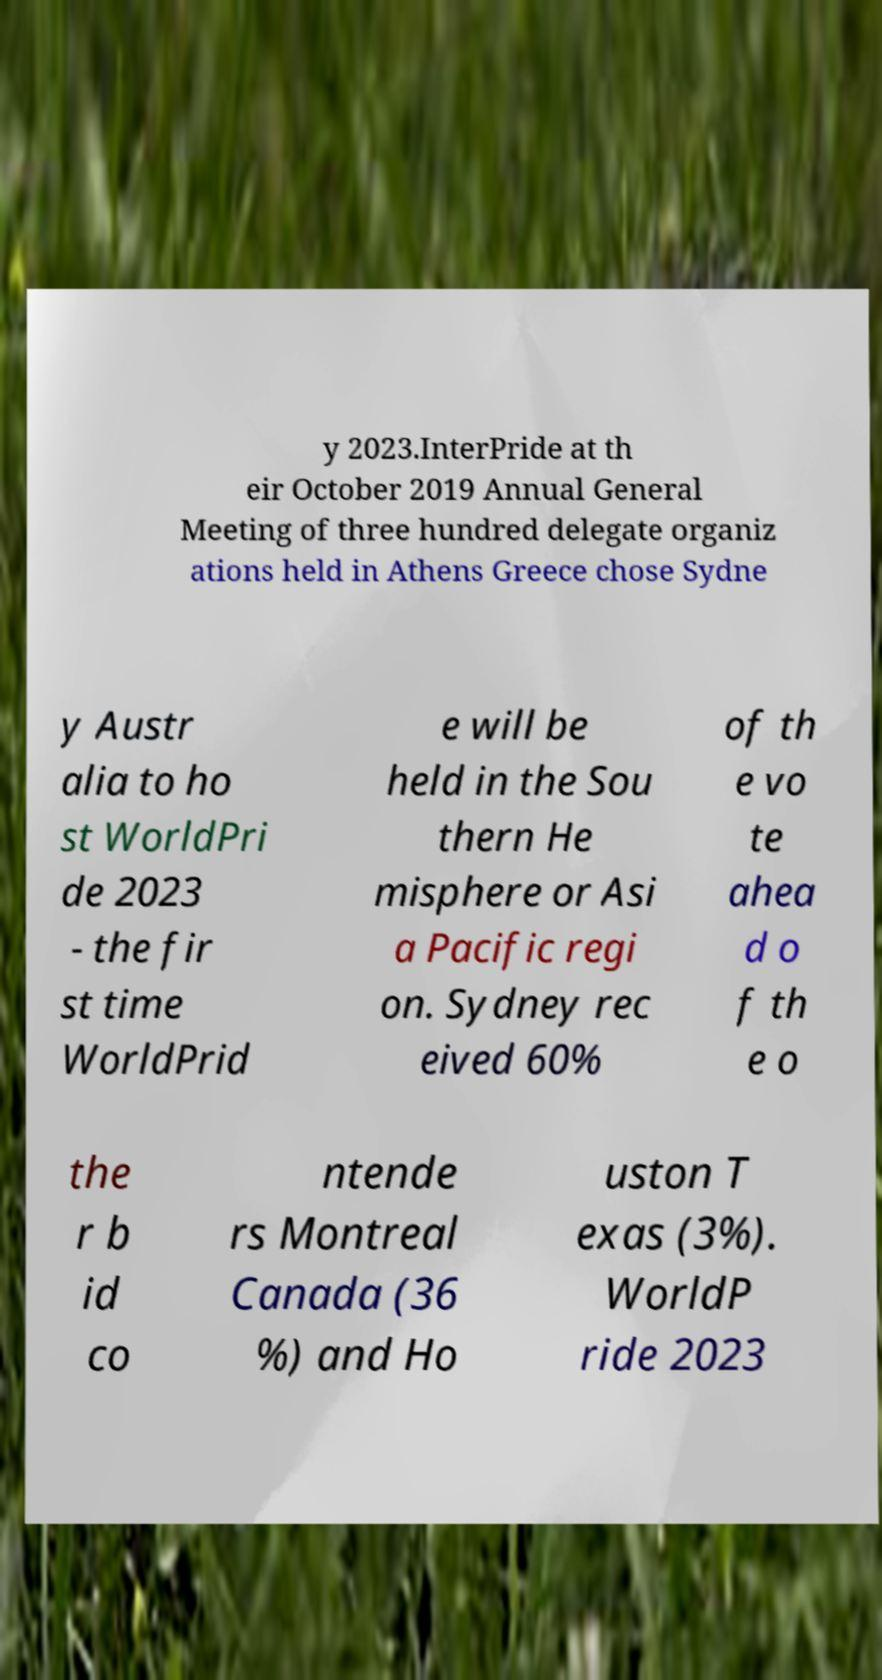There's text embedded in this image that I need extracted. Can you transcribe it verbatim? y 2023.InterPride at th eir October 2019 Annual General Meeting of three hundred delegate organiz ations held in Athens Greece chose Sydne y Austr alia to ho st WorldPri de 2023 - the fir st time WorldPrid e will be held in the Sou thern He misphere or Asi a Pacific regi on. Sydney rec eived 60% of th e vo te ahea d o f th e o the r b id co ntende rs Montreal Canada (36 %) and Ho uston T exas (3%). WorldP ride 2023 